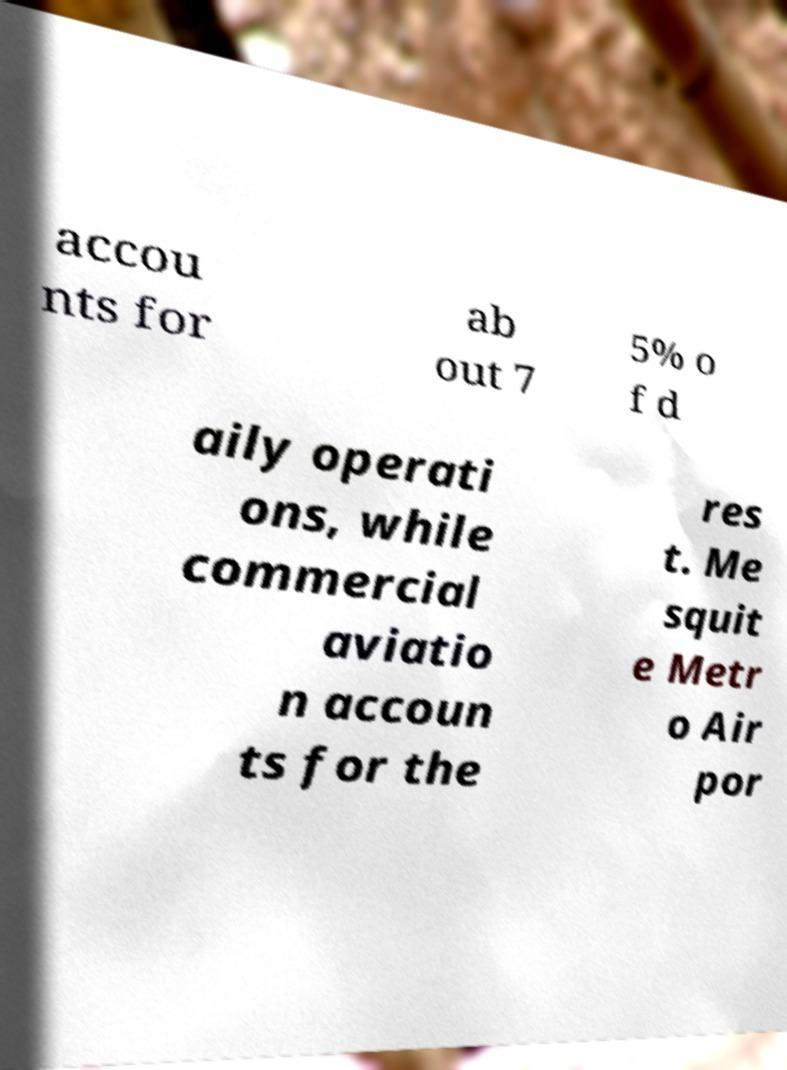Could you assist in decoding the text presented in this image and type it out clearly? accou nts for ab out 7 5% o f d aily operati ons, while commercial aviatio n accoun ts for the res t. Me squit e Metr o Air por 